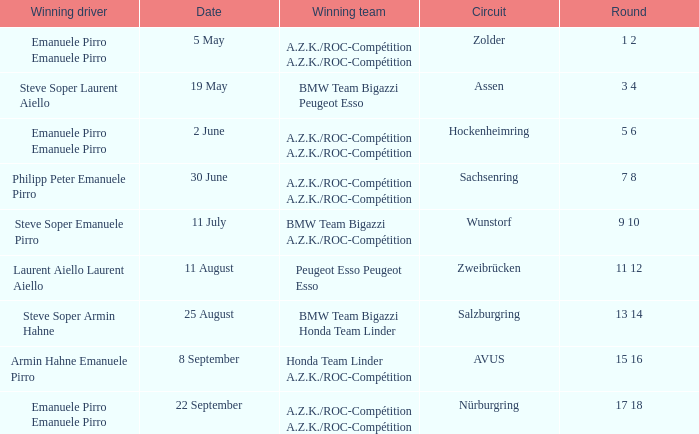What is the round on 30 June with a.z.k./roc-compétition a.z.k./roc-compétition as the winning team? 7 8. 